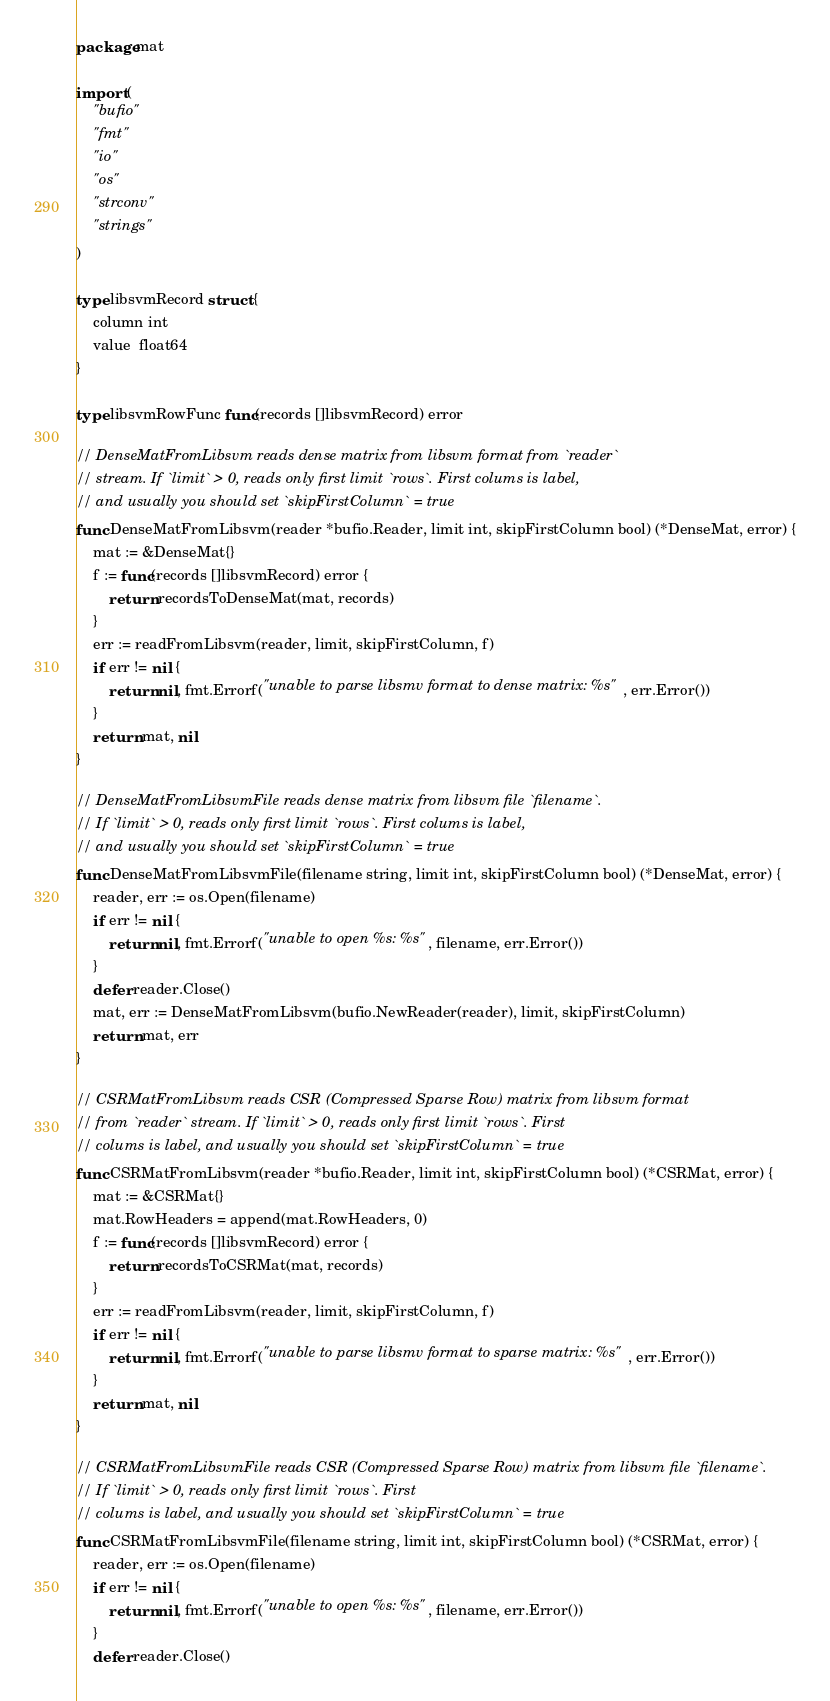Convert code to text. <code><loc_0><loc_0><loc_500><loc_500><_Go_>package mat

import (
	"bufio"
	"fmt"
	"io"
	"os"
	"strconv"
	"strings"
)

type libsvmRecord struct {
	column int
	value  float64
}

type libsvmRowFunc func(records []libsvmRecord) error

// DenseMatFromLibsvm reads dense matrix from libsvm format from `reader`
// stream. If `limit` > 0, reads only first limit `rows`. First colums is label,
// and usually you should set `skipFirstColumn` = true
func DenseMatFromLibsvm(reader *bufio.Reader, limit int, skipFirstColumn bool) (*DenseMat, error) {
	mat := &DenseMat{}
	f := func(records []libsvmRecord) error {
		return recordsToDenseMat(mat, records)
	}
	err := readFromLibsvm(reader, limit, skipFirstColumn, f)
	if err != nil {
		return nil, fmt.Errorf("unable to parse libsmv format to dense matrix: %s", err.Error())
	}
	return mat, nil
}

// DenseMatFromLibsvmFile reads dense matrix from libsvm file `filename`.
// If `limit` > 0, reads only first limit `rows`. First colums is label,
// and usually you should set `skipFirstColumn` = true
func DenseMatFromLibsvmFile(filename string, limit int, skipFirstColumn bool) (*DenseMat, error) {
	reader, err := os.Open(filename)
	if err != nil {
		return nil, fmt.Errorf("unable to open %s: %s", filename, err.Error())
	}
	defer reader.Close()
	mat, err := DenseMatFromLibsvm(bufio.NewReader(reader), limit, skipFirstColumn)
	return mat, err
}

// CSRMatFromLibsvm reads CSR (Compressed Sparse Row) matrix from libsvm format
// from `reader` stream. If `limit` > 0, reads only first limit `rows`. First
// colums is label, and usually you should set `skipFirstColumn` = true
func CSRMatFromLibsvm(reader *bufio.Reader, limit int, skipFirstColumn bool) (*CSRMat, error) {
	mat := &CSRMat{}
	mat.RowHeaders = append(mat.RowHeaders, 0)
	f := func(records []libsvmRecord) error {
		return recordsToCSRMat(mat, records)
	}
	err := readFromLibsvm(reader, limit, skipFirstColumn, f)
	if err != nil {
		return nil, fmt.Errorf("unable to parse libsmv format to sparse matrix: %s", err.Error())
	}
	return mat, nil
}

// CSRMatFromLibsvmFile reads CSR (Compressed Sparse Row) matrix from libsvm file `filename`.
// If `limit` > 0, reads only first limit `rows`. First
// colums is label, and usually you should set `skipFirstColumn` = true
func CSRMatFromLibsvmFile(filename string, limit int, skipFirstColumn bool) (*CSRMat, error) {
	reader, err := os.Open(filename)
	if err != nil {
		return nil, fmt.Errorf("unable to open %s: %s", filename, err.Error())
	}
	defer reader.Close()</code> 